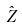Convert formula to latex. <formula><loc_0><loc_0><loc_500><loc_500>\hat { Z }</formula> 